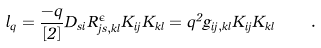Convert formula to latex. <formula><loc_0><loc_0><loc_500><loc_500>l _ { q } = \frac { - q } { \left [ 2 \right ] } D _ { s i } \hat { R } _ { j s , k l } ^ { \epsilon } K _ { i j } K _ { k l } = q ^ { 2 } g _ { i j , k l } K _ { i j } K _ { k l } \quad .</formula> 